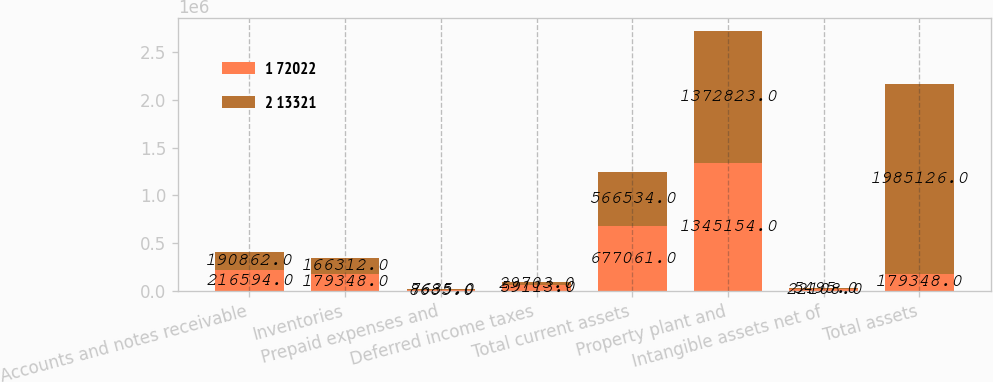<chart> <loc_0><loc_0><loc_500><loc_500><stacked_bar_chart><ecel><fcel>Accounts and notes receivable<fcel>Inventories<fcel>Prepaid expenses and<fcel>Deferred income taxes<fcel>Total current assets<fcel>Property plant and<fcel>Intangible assets net of<fcel>Total assets<nl><fcel>1 72022<fcel>216594<fcel>179348<fcel>8685<fcel>59113<fcel>677061<fcel>1.34515e+06<fcel>22108<fcel>179348<nl><fcel>2 13321<fcel>190862<fcel>166312<fcel>7635<fcel>29703<fcel>566534<fcel>1.37282e+06<fcel>5495<fcel>1.98513e+06<nl></chart> 